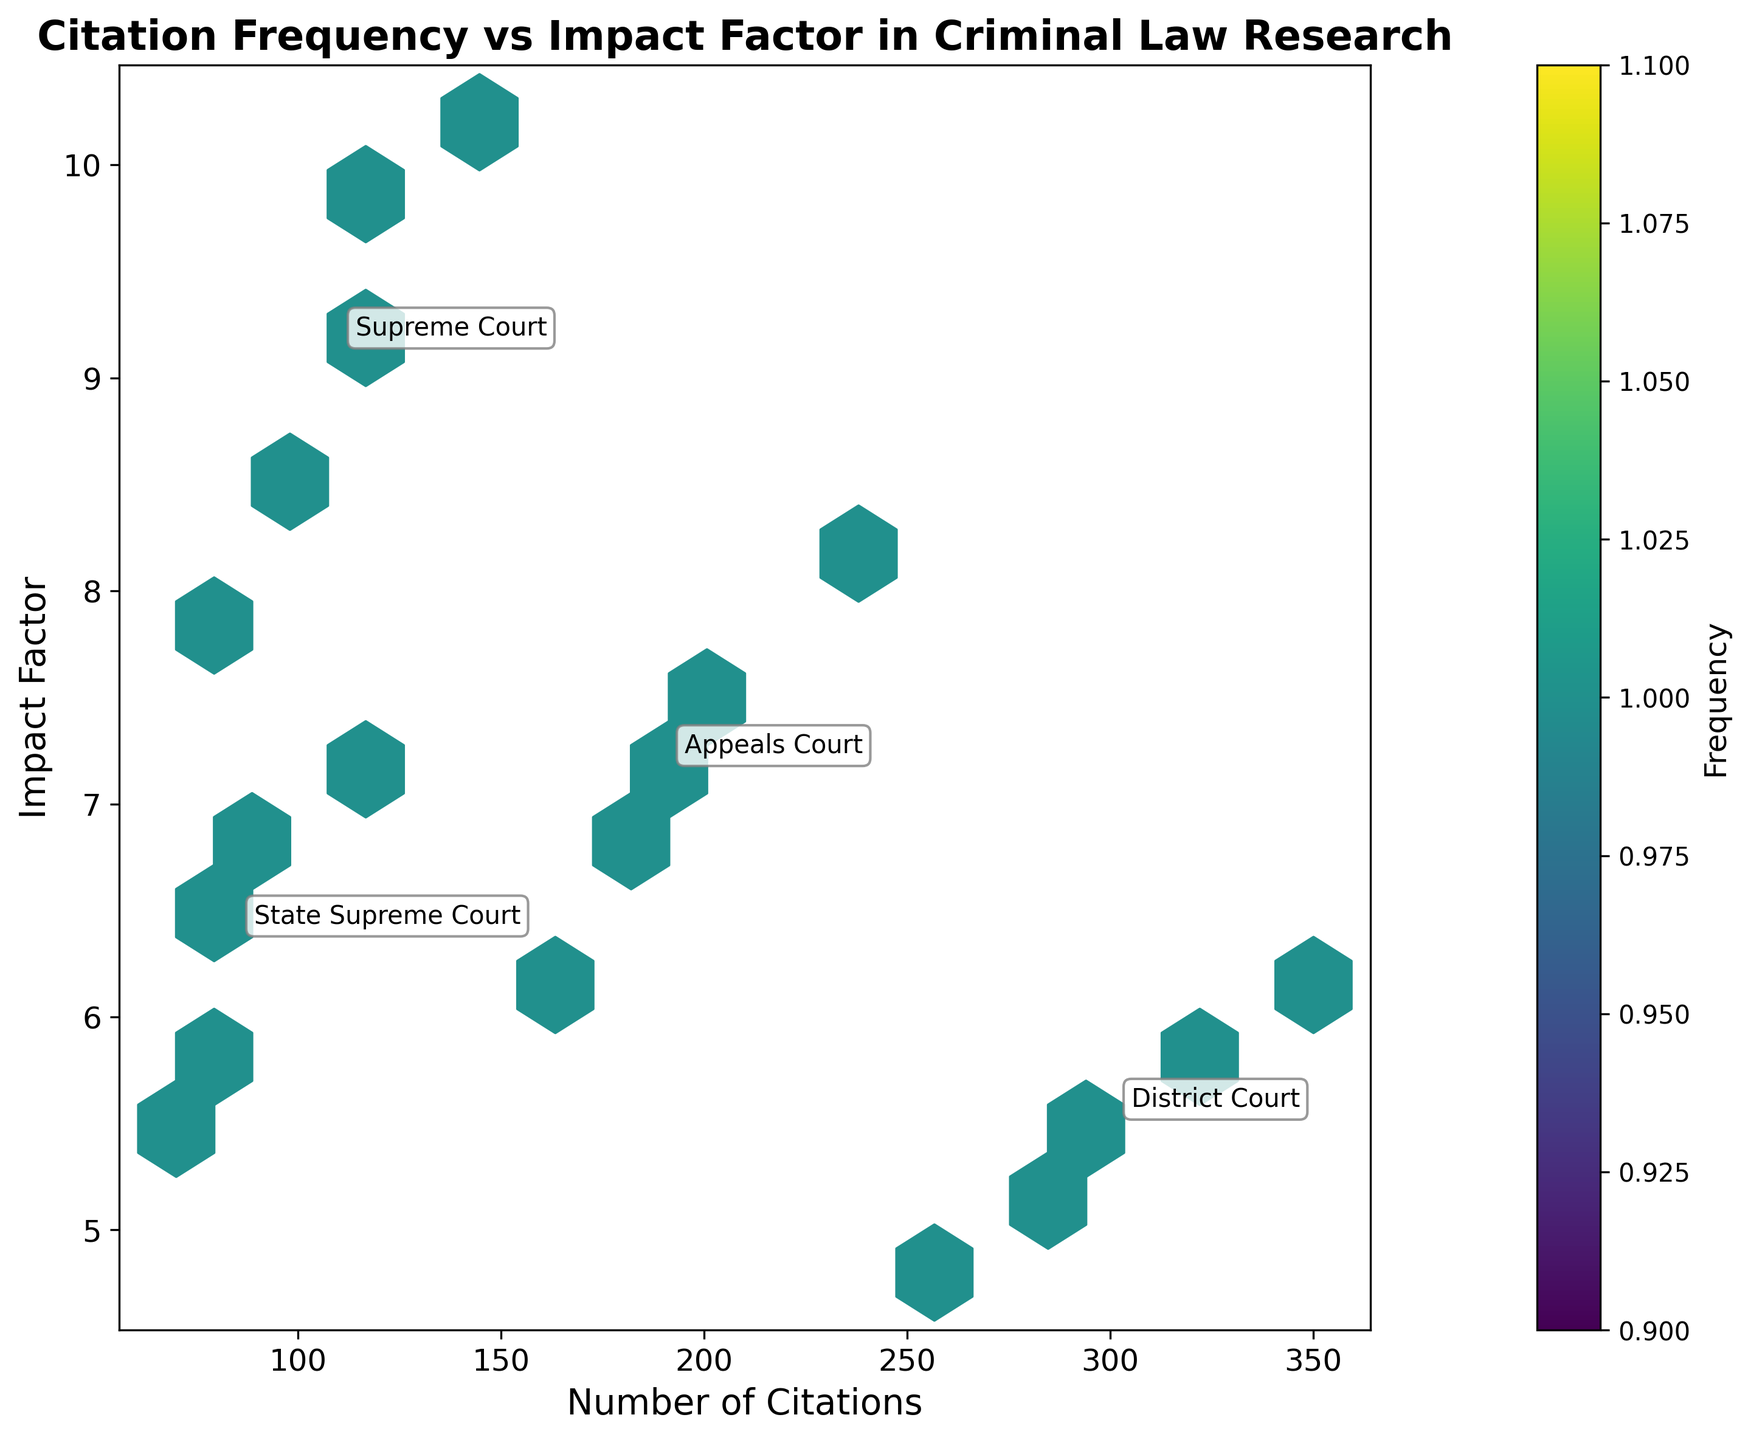How many levels of courts are represented in the plot? Examine the annotations or clusters in the hexbin plot to count distinct court levels. You should see labels like "Supreme Court," "Appeals Court," "District Court," and "State Supreme Court."
Answer: 4 What is the range of impact factors for Supreme Court citations? Look at the hexbin plot and identify the highest and lowest points on the y-axis for the Supreme Court labeled annotations. The impact factors range approximately from 7.9 to 10.2.
Answer: 7.9 to 10.2 Which court level has the highest number of citations? Observe the x-values where each court is annotated and identify the maximum citations count. The District Court has values clustered around 260 to 350.
Answer: District Court What's the average impact factor for State Supreme Court citations? Locate the clusters labeled "State Supreme Court" and note the y-values. Calculate the average of these values (6.8 + 5.9 + 7.3 + 5.5 + 6.4) / 5 = 6.38.
Answer: 6.38 Between Supreme Court and Appeals Court, which one has a higher average number of citations? Add the total citations and divide by the number of entries for each court. For Supreme Court: (120+95+150+80+110) / 5 = 111. For Appeals Court: (200+180+230+160+190) / 5 = 192. Thus, Appeals Court has a higher average.
Answer: Appeals Court Do District Court citations tend to have higher or lower impact factors compared to Appeals Court citations? Compare the y-values of the clusters labeled "District Court" with those labeled "Appeals Court." District Court clusters hover around 5.6, while Appeals Court clusters are around 7.2. District Court generally has lower impact factors.
Answer: Lower What is the color representing the highest frequency in the hexbin plot? Identify the darkest color on the colormap used in the plot, which signifies the highest frequency of data points. The color at the top end of the 'viridis' colormap is a bright yellow-green.
Answer: Yellow-green How does the impact factor for papers cited in the State Supreme Court compare to those cited in the Supreme Court? Compare the average y-values of clusters labeled "State Supreme Court" and "Supreme Court." State Supreme Court has averages around 6.38, while Supreme Court has averages ranging from 7.9 to 10.2, indicating Supreme Court typically has higher impact factors.
Answer: Lower Which two court levels have the most overlap in citation counts? Look at the x-axis regions where different courts' data points cluster. Supreme Court (80-150) and State Supreme Court (70-110) have overlapping citation counts.
Answer: Supreme Court and State Supreme Court Is there any court level that doesn't appear to follow a clear correlation between citation count and impact factor? Examine the scatter density pattern in the hexbin plot for each court label. The State Supreme Court appears less correlated compared to others because the impact factors and citation counts are more scattered without a clear trend.
Answer: State Supreme Court 